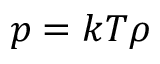Convert formula to latex. <formula><loc_0><loc_0><loc_500><loc_500>p = k T \rho</formula> 